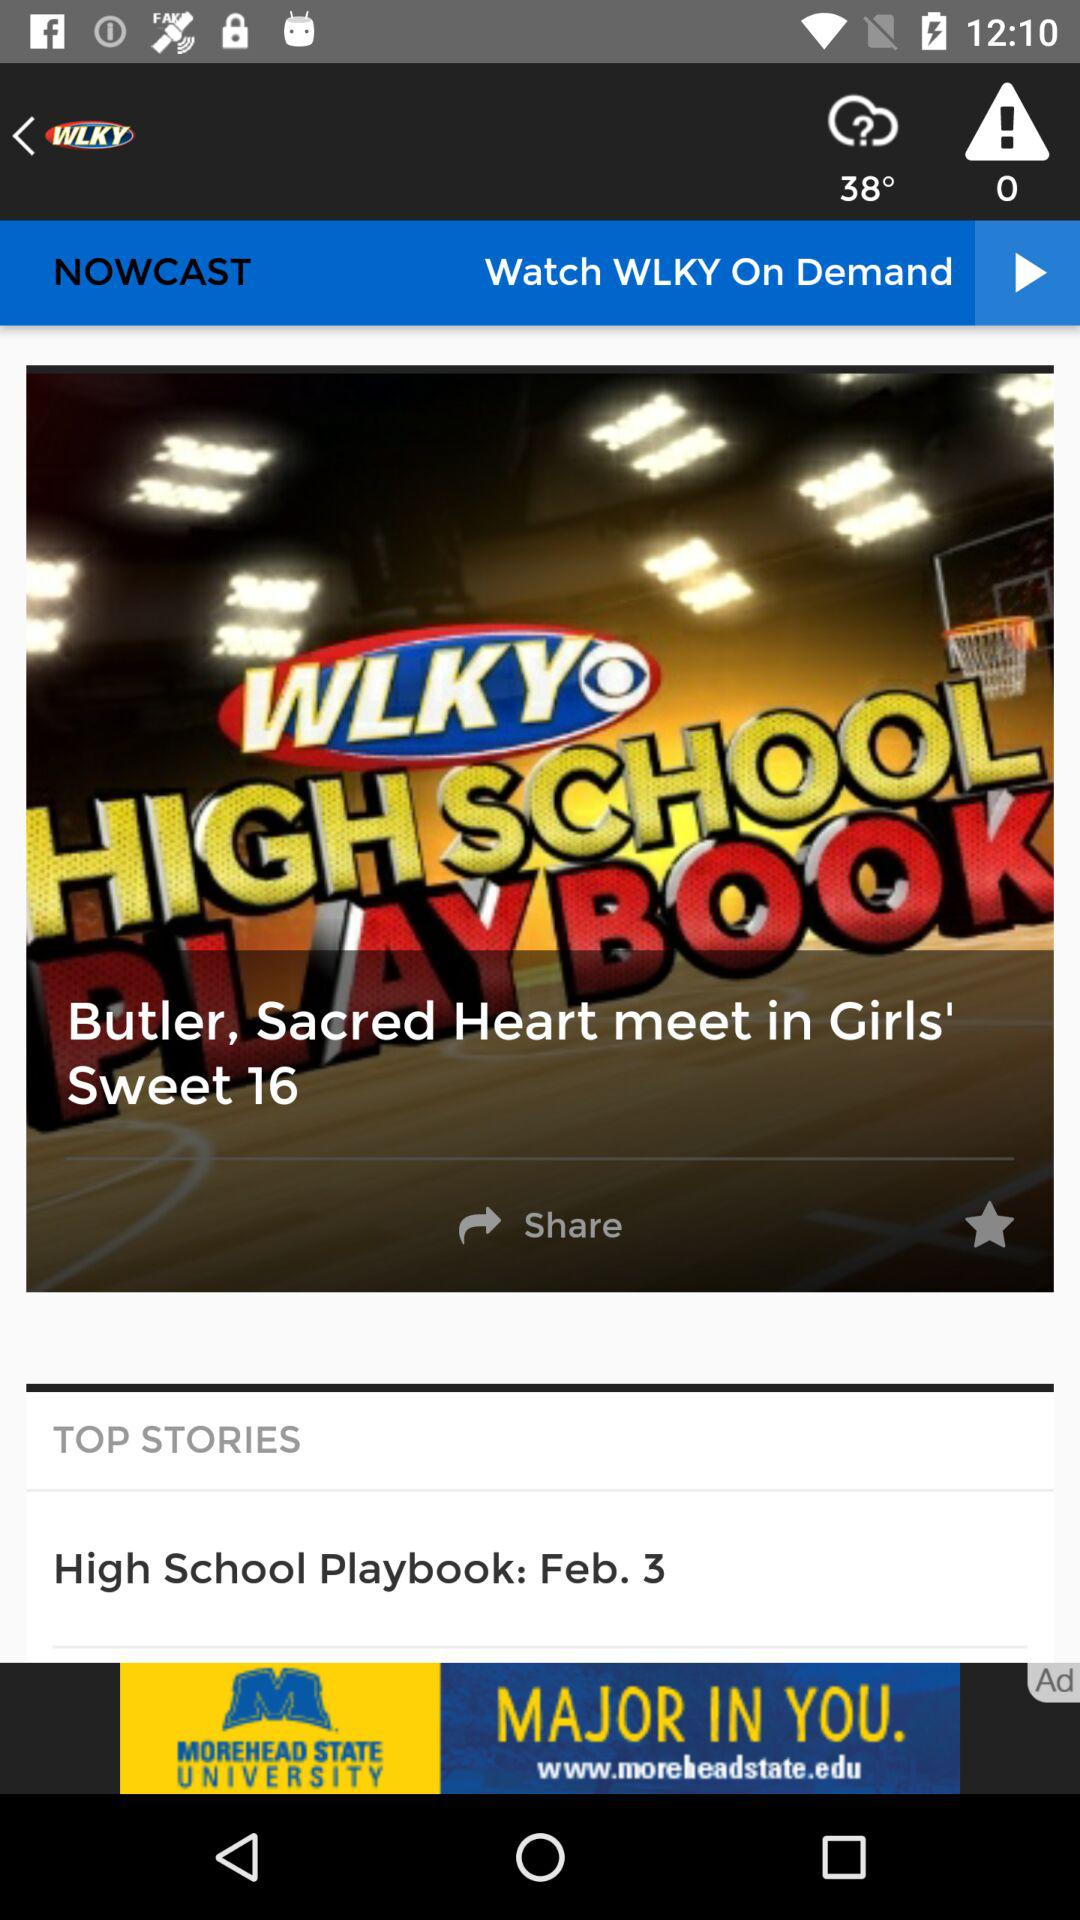How many alerts are there? There are 0 alerts. 